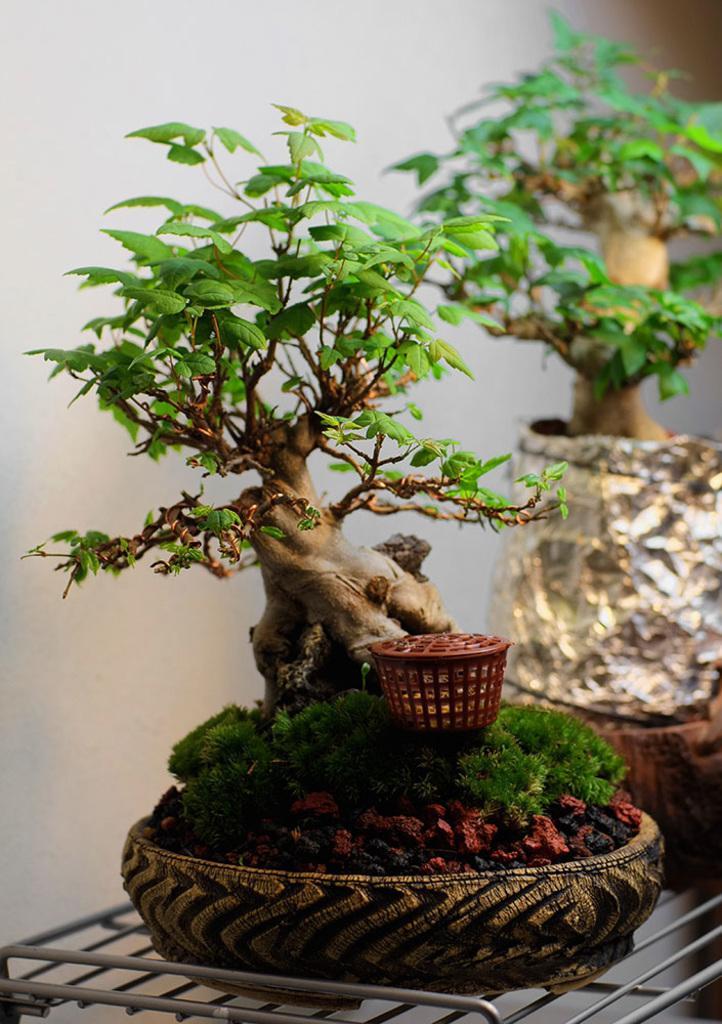How would you summarize this image in a sentence or two? In this image I can see flower pots kept on the table and in the flower pot I can see plants and background is white. 